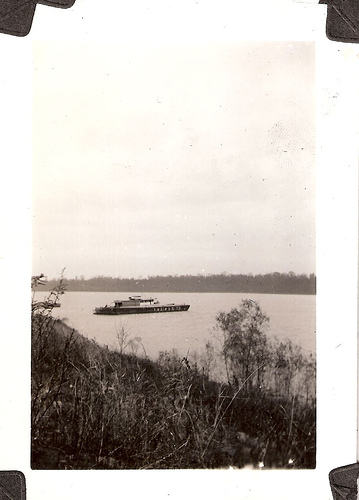<image>
Is there a boat on the shore? No. The boat is not positioned on the shore. They may be near each other, but the boat is not supported by or resting on top of the shore. 